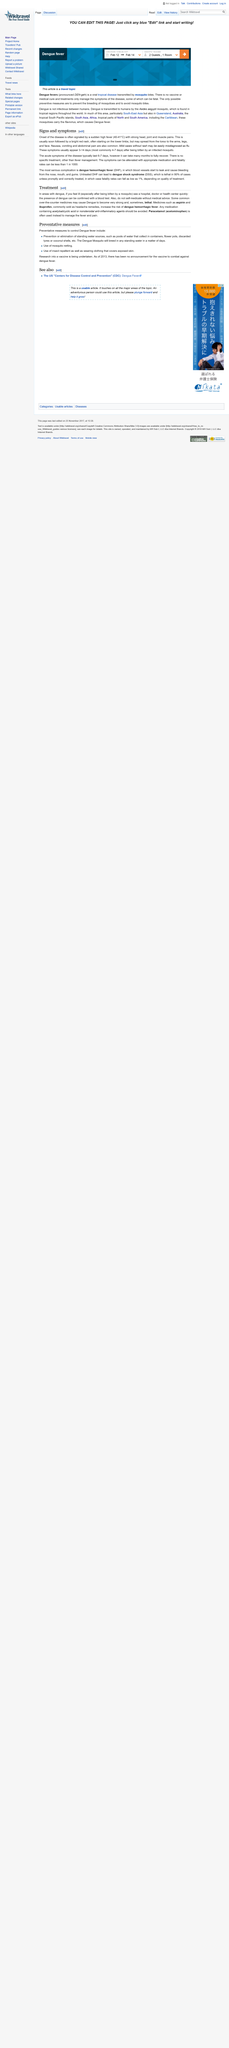Indicate a few pertinent items in this graphic. Seeing a hospital, doctor, or health center quickly is an essential aspect of treating dengue fever. Dengue can be found in Queensland, Australia, one of the places. Medicines such as aspirin and ibuprofen can increase the risk of developing dengue hemorrhagic fever, a severe and potentially life-threatening complication of dengue fever. The article on Dengue fever falls into the travel topic category. The fatality rate is less than 1 in 1000. 